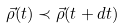Convert formula to latex. <formula><loc_0><loc_0><loc_500><loc_500>\vec { \rho } ( t ) \prec \vec { \rho } ( t + d t )</formula> 